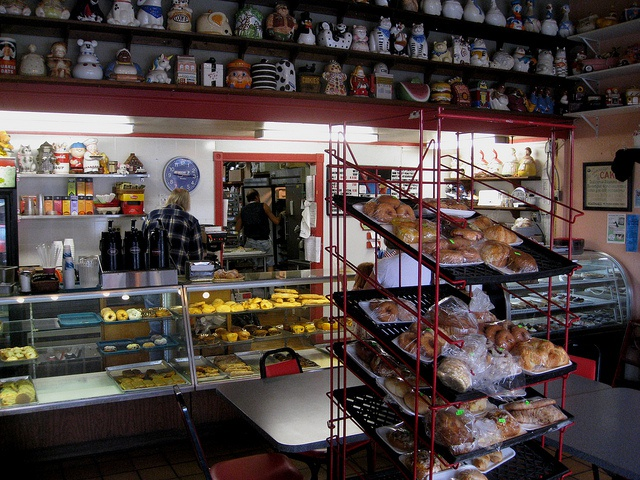Describe the objects in this image and their specific colors. I can see dining table in black, gray, darkgray, and lightgray tones, people in black and gray tones, donut in black, maroon, and gray tones, chair in black, maroon, gray, and navy tones, and people in black, gray, and maroon tones in this image. 